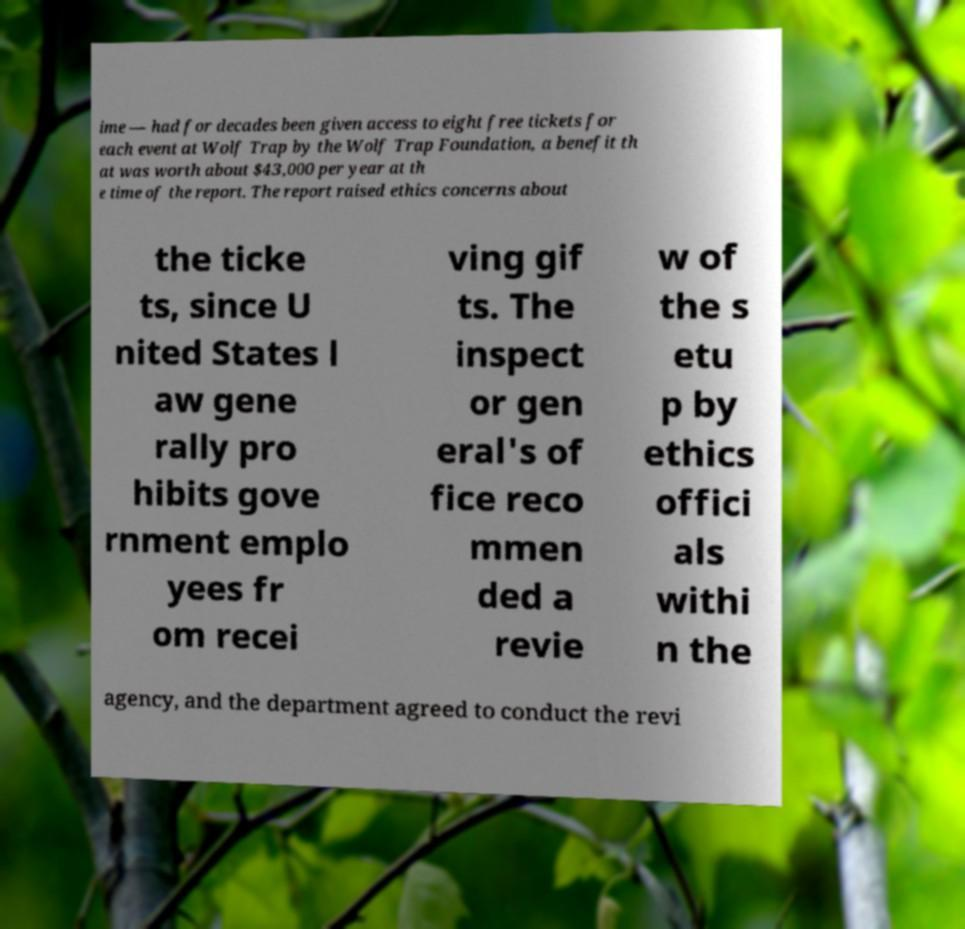For documentation purposes, I need the text within this image transcribed. Could you provide that? ime — had for decades been given access to eight free tickets for each event at Wolf Trap by the Wolf Trap Foundation, a benefit th at was worth about $43,000 per year at th e time of the report. The report raised ethics concerns about the ticke ts, since U nited States l aw gene rally pro hibits gove rnment emplo yees fr om recei ving gif ts. The inspect or gen eral's of fice reco mmen ded a revie w of the s etu p by ethics offici als withi n the agency, and the department agreed to conduct the revi 